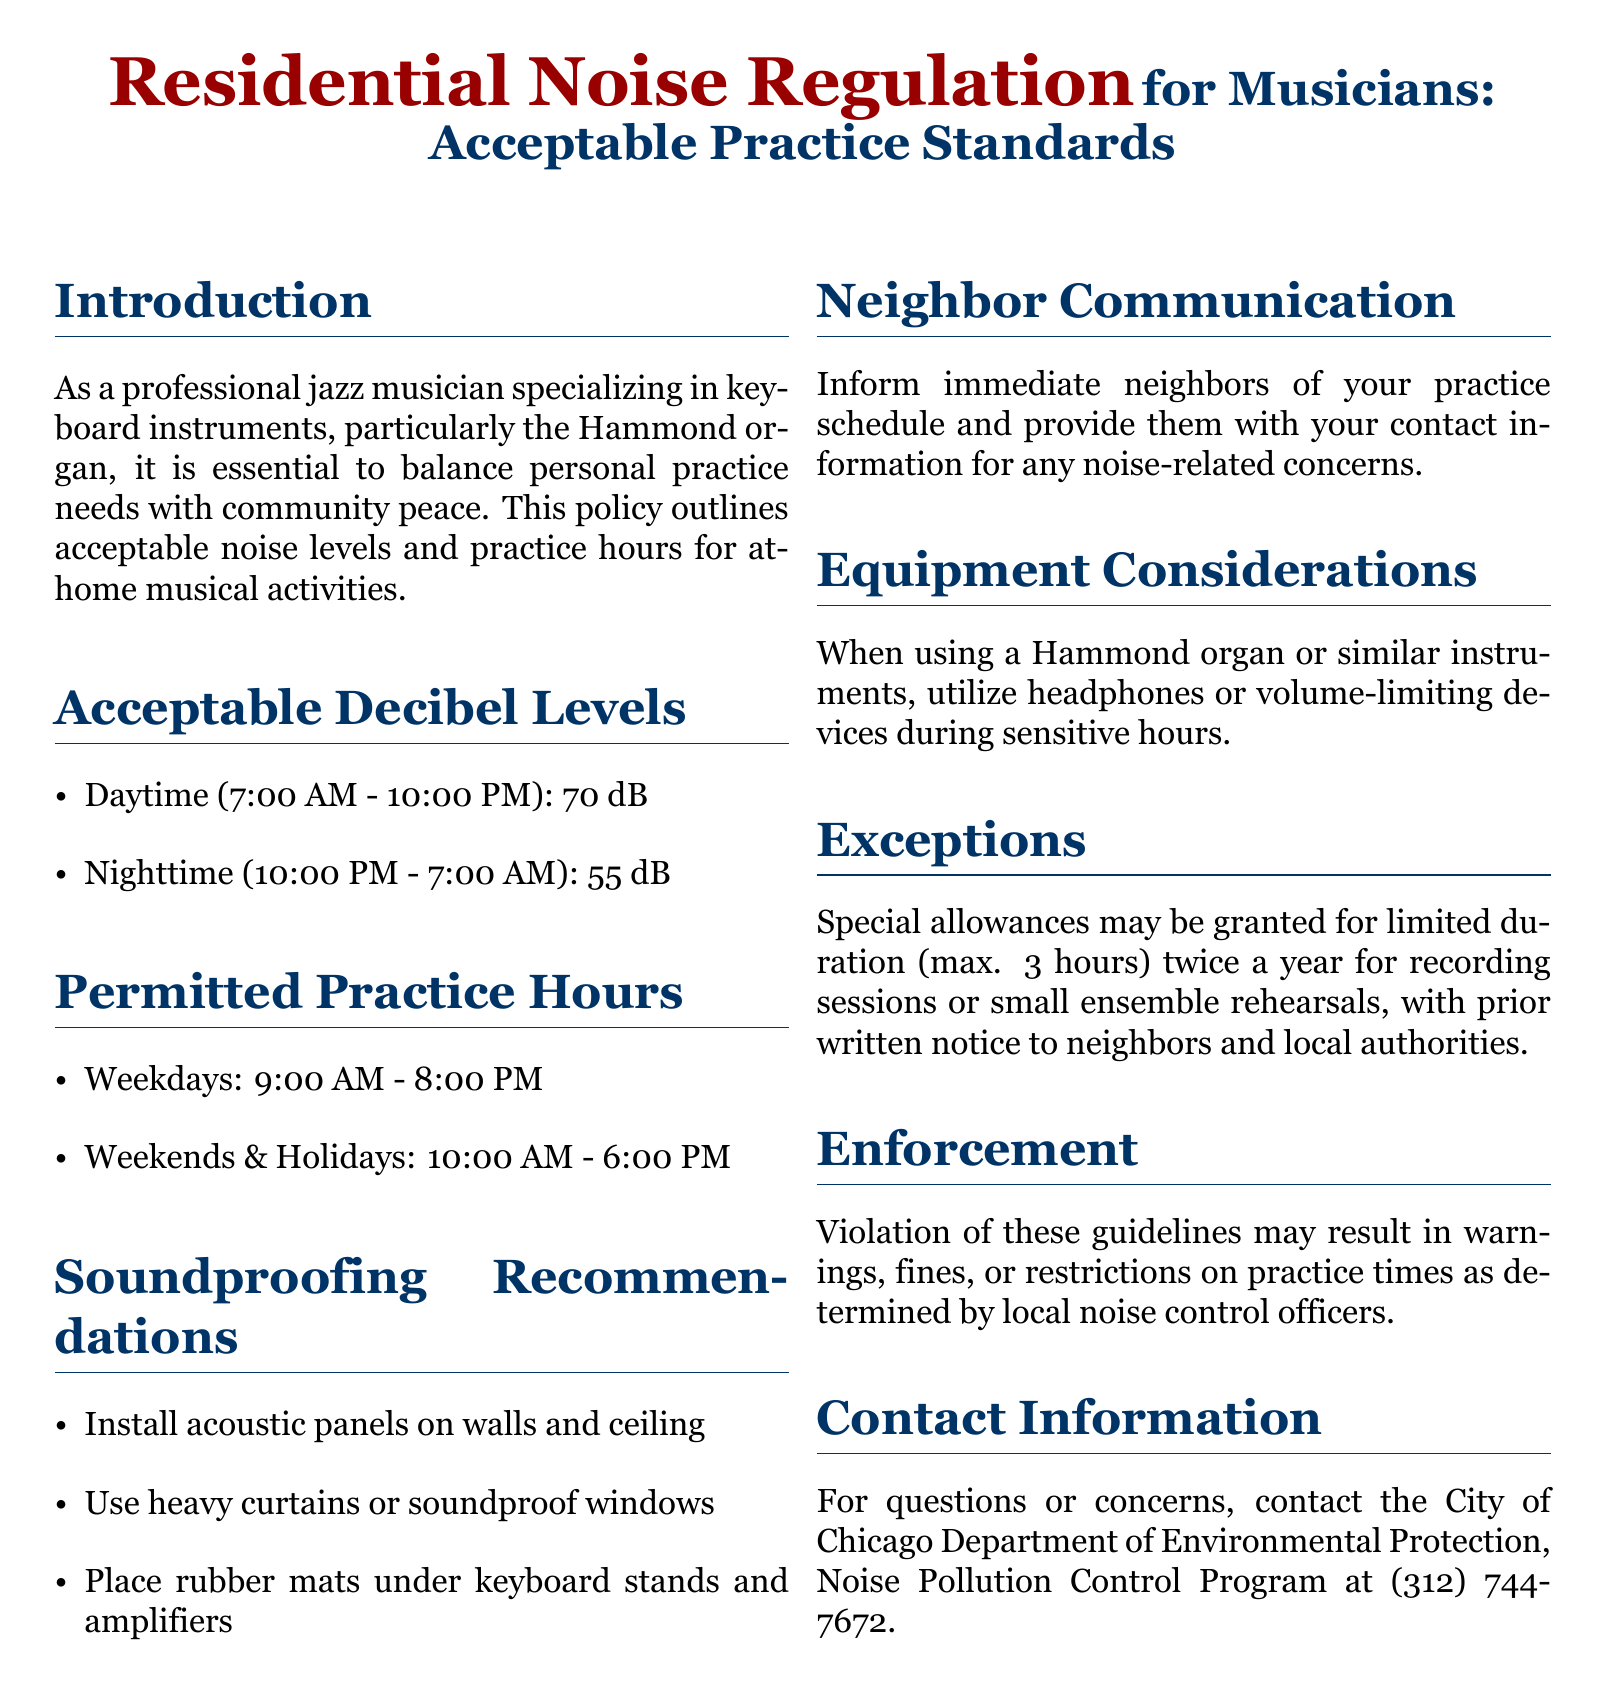what is the maximum allowable decibel level during the daytime? The document specifies that the maximum allowable decibel level during the daytime (7:00 AM - 10:00 PM) is 70 dB.
Answer: 70 dB what are the permitted practice hours on weekends? The document lists the permitted practice hours on weekends as 10:00 AM - 6:00 PM.
Answer: 10:00 AM - 6:00 PM what is the recommended soundproofing method for keyboard stands? The document recommends placing rubber mats under keyboard stands and amplifiers for soundproofing.
Answer: Rubber mats how many hours of exceptions may be granted for recording sessions? The document states that special allowances may be granted for a maximum duration of 3 hours for recording sessions or small ensemble rehearsals.
Answer: 3 hours who should be informed about your practice schedule? The document advises informing immediate neighbors of your practice schedule.
Answer: Immediate neighbors what is the enforcement consequence for violating the noise guidelines? The document mentions that violations may result in warnings, fines, or restrictions on practice times.
Answer: Warnings, fines, or restrictions what time does nighttime practice begin? The document indicates that nighttime practice begins at 10:00 PM.
Answer: 10:00 PM what is the contact number for noise-related concerns? The document provides the contact number for the City of Chicago Department of Environmental Protection, which is (312) 744-7672.
Answer: (312) 744-7672 